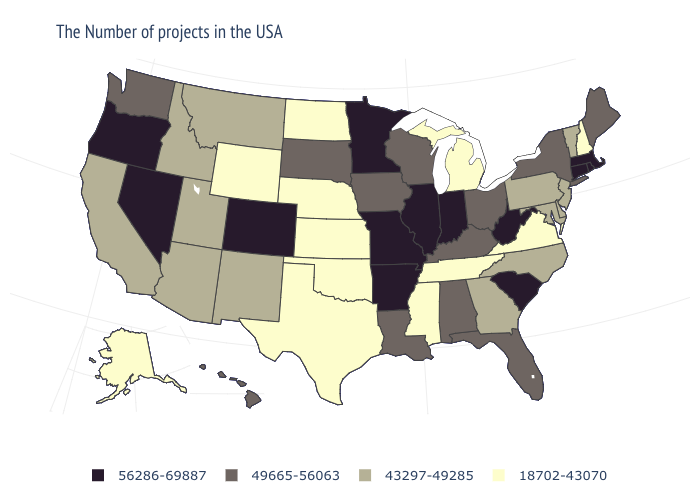Does Minnesota have a higher value than South Carolina?
Quick response, please. No. Does the first symbol in the legend represent the smallest category?
Keep it brief. No. What is the highest value in the MidWest ?
Quick response, please. 56286-69887. Does the map have missing data?
Write a very short answer. No. Name the states that have a value in the range 18702-43070?
Write a very short answer. New Hampshire, Virginia, Michigan, Tennessee, Mississippi, Kansas, Nebraska, Oklahoma, Texas, North Dakota, Wyoming, Alaska. Is the legend a continuous bar?
Short answer required. No. Among the states that border Vermont , which have the lowest value?
Short answer required. New Hampshire. Among the states that border Maine , which have the lowest value?
Concise answer only. New Hampshire. What is the highest value in states that border Mississippi?
Answer briefly. 56286-69887. What is the value of Virginia?
Write a very short answer. 18702-43070. What is the value of Maine?
Give a very brief answer. 49665-56063. How many symbols are there in the legend?
Give a very brief answer. 4. What is the value of California?
Give a very brief answer. 43297-49285. What is the highest value in the USA?
Give a very brief answer. 56286-69887. 